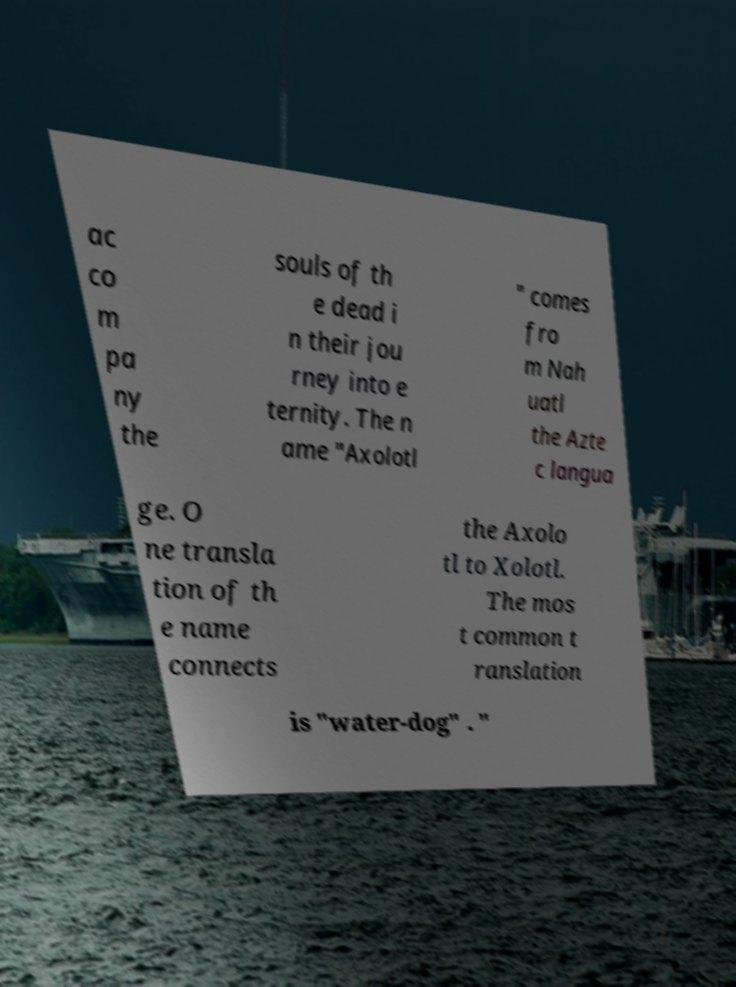What messages or text are displayed in this image? I need them in a readable, typed format. ac co m pa ny the souls of th e dead i n their jou rney into e ternity. The n ame "Axolotl " comes fro m Nah uatl the Azte c langua ge. O ne transla tion of th e name connects the Axolo tl to Xolotl. The mos t common t ranslation is "water-dog" . " 